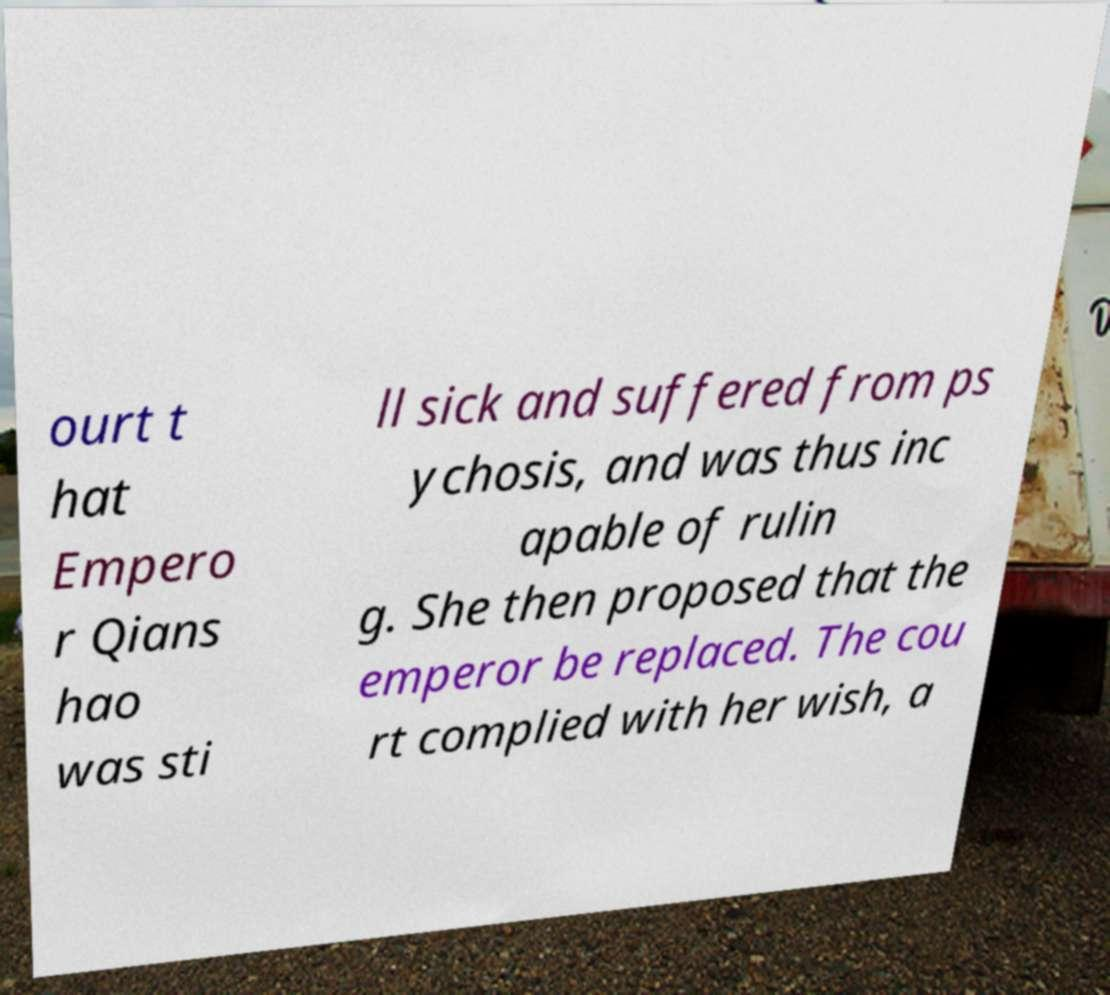Could you assist in decoding the text presented in this image and type it out clearly? ourt t hat Empero r Qians hao was sti ll sick and suffered from ps ychosis, and was thus inc apable of rulin g. She then proposed that the emperor be replaced. The cou rt complied with her wish, a 